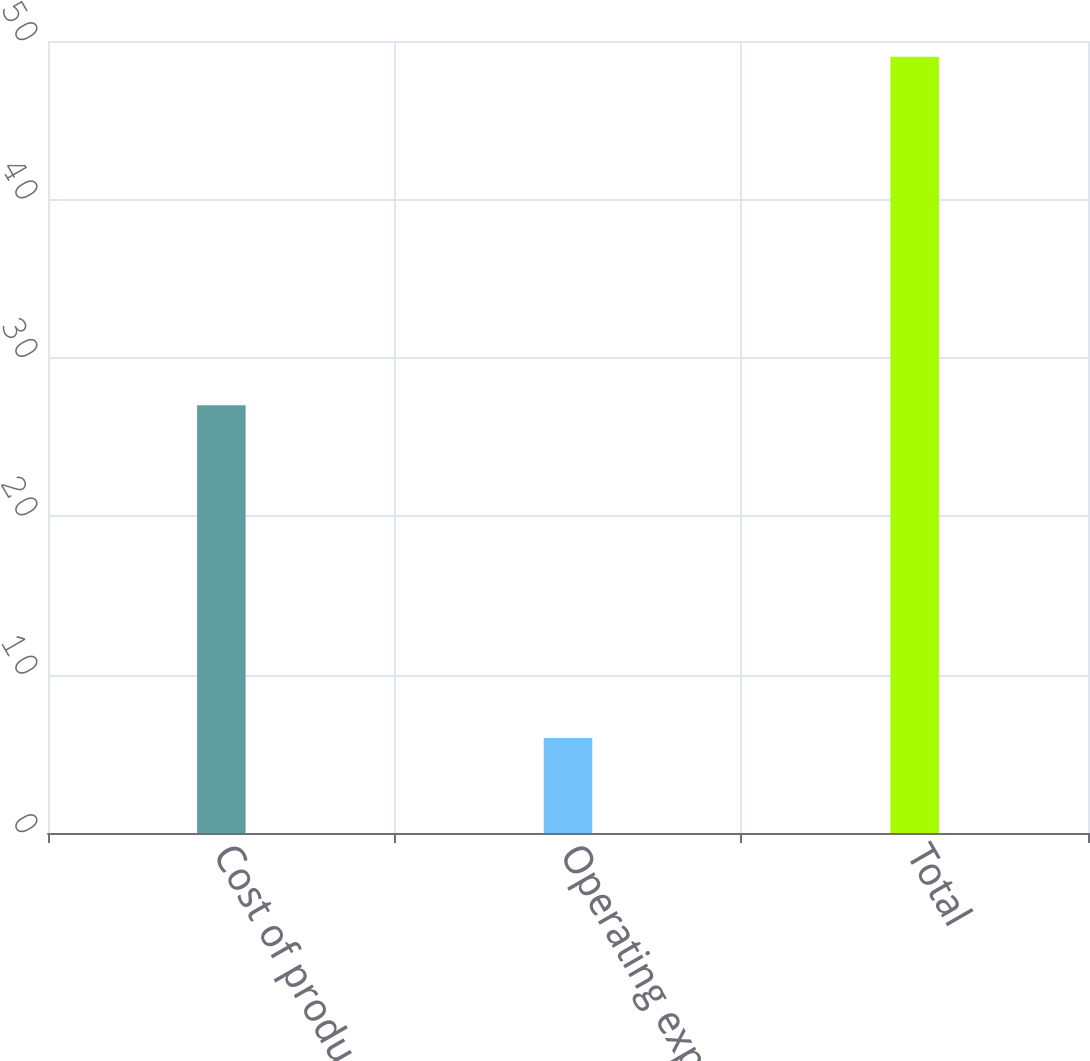<chart> <loc_0><loc_0><loc_500><loc_500><bar_chart><fcel>Cost of product<fcel>Operating expenses<fcel>Total<nl><fcel>27<fcel>6<fcel>49<nl></chart> 